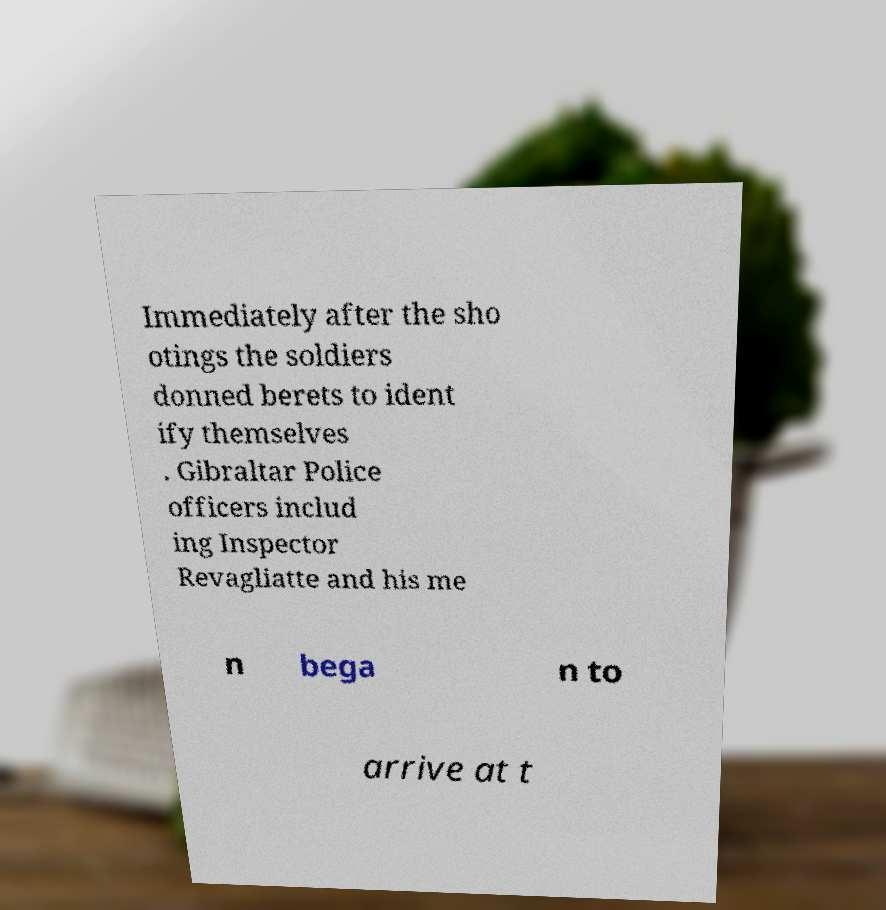Can you accurately transcribe the text from the provided image for me? Immediately after the sho otings the soldiers donned berets to ident ify themselves . Gibraltar Police officers includ ing Inspector Revagliatte and his me n bega n to arrive at t 